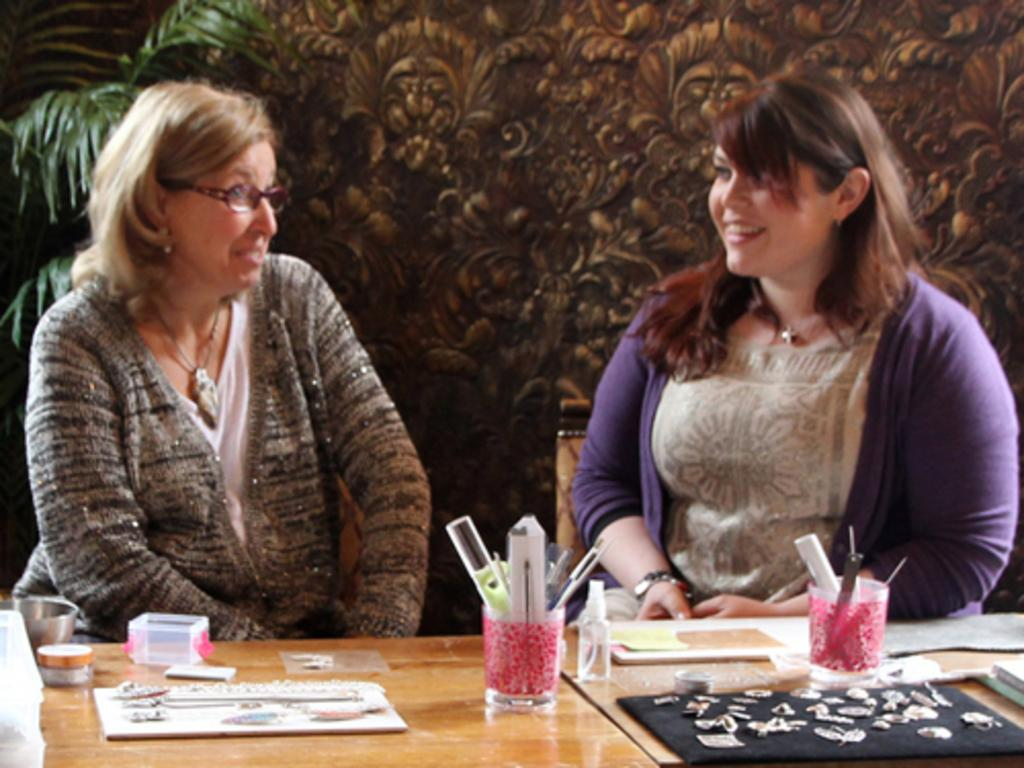How many people are in the image? There are two ladies in the image. What are the ladies doing in the image? The ladies are sitting in chairs and talking to each other. What is in front of the ladies? There is a table in front of the ladies. What can be seen on the table? There are objects on the table. What type of mitten is the manager using for arithmetic in the image? There is no mitten, manager, or arithmetic present in the image. 